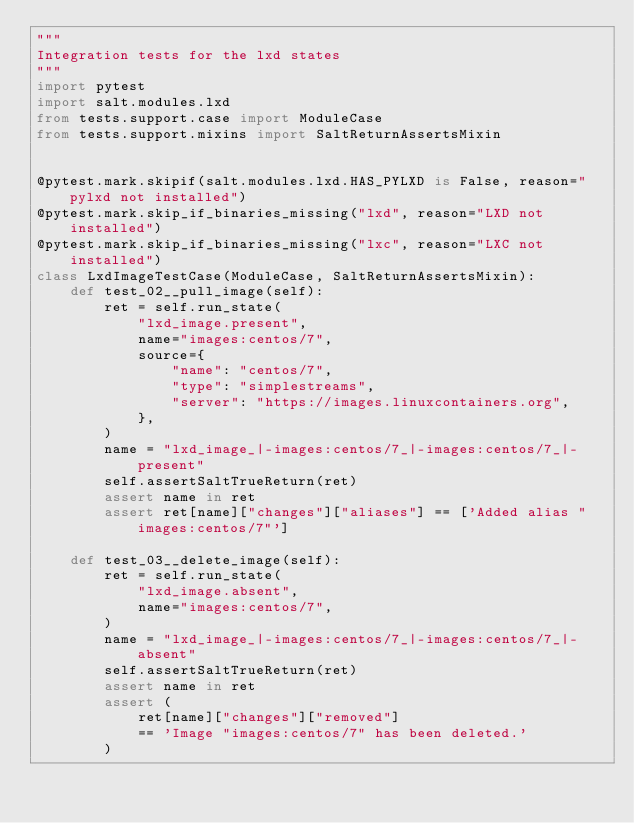<code> <loc_0><loc_0><loc_500><loc_500><_Python_>"""
Integration tests for the lxd states
"""
import pytest
import salt.modules.lxd
from tests.support.case import ModuleCase
from tests.support.mixins import SaltReturnAssertsMixin


@pytest.mark.skipif(salt.modules.lxd.HAS_PYLXD is False, reason="pylxd not installed")
@pytest.mark.skip_if_binaries_missing("lxd", reason="LXD not installed")
@pytest.mark.skip_if_binaries_missing("lxc", reason="LXC not installed")
class LxdImageTestCase(ModuleCase, SaltReturnAssertsMixin):
    def test_02__pull_image(self):
        ret = self.run_state(
            "lxd_image.present",
            name="images:centos/7",
            source={
                "name": "centos/7",
                "type": "simplestreams",
                "server": "https://images.linuxcontainers.org",
            },
        )
        name = "lxd_image_|-images:centos/7_|-images:centos/7_|-present"
        self.assertSaltTrueReturn(ret)
        assert name in ret
        assert ret[name]["changes"]["aliases"] == ['Added alias "images:centos/7"']

    def test_03__delete_image(self):
        ret = self.run_state(
            "lxd_image.absent",
            name="images:centos/7",
        )
        name = "lxd_image_|-images:centos/7_|-images:centos/7_|-absent"
        self.assertSaltTrueReturn(ret)
        assert name in ret
        assert (
            ret[name]["changes"]["removed"]
            == 'Image "images:centos/7" has been deleted.'
        )
</code> 